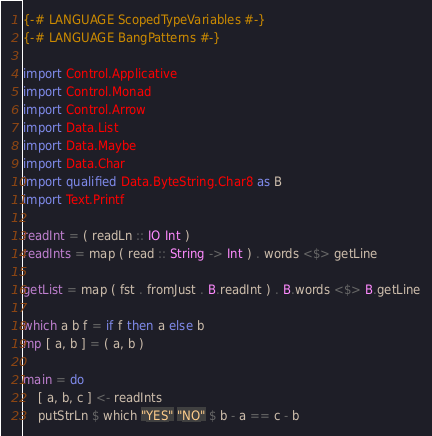Convert code to text. <code><loc_0><loc_0><loc_500><loc_500><_Haskell_>{-# LANGUAGE ScopedTypeVariables #-}
{-# LANGUAGE BangPatterns #-}

import Control.Applicative
import Control.Monad
import Control.Arrow
import Data.List
import Data.Maybe
import Data.Char
import qualified Data.ByteString.Char8 as B
import Text.Printf

readInt = ( readLn :: IO Int )
readInts = map ( read :: String -> Int ) . words <$> getLine

getList = map ( fst . fromJust . B.readInt ) . B.words <$> B.getLine

which a b f = if f then a else b
mp [ a, b ] = ( a, b )

main = do
	[ a, b, c ] <- readInts
	putStrLn $ which "YES" "NO" $ b - a == c - b
</code> 